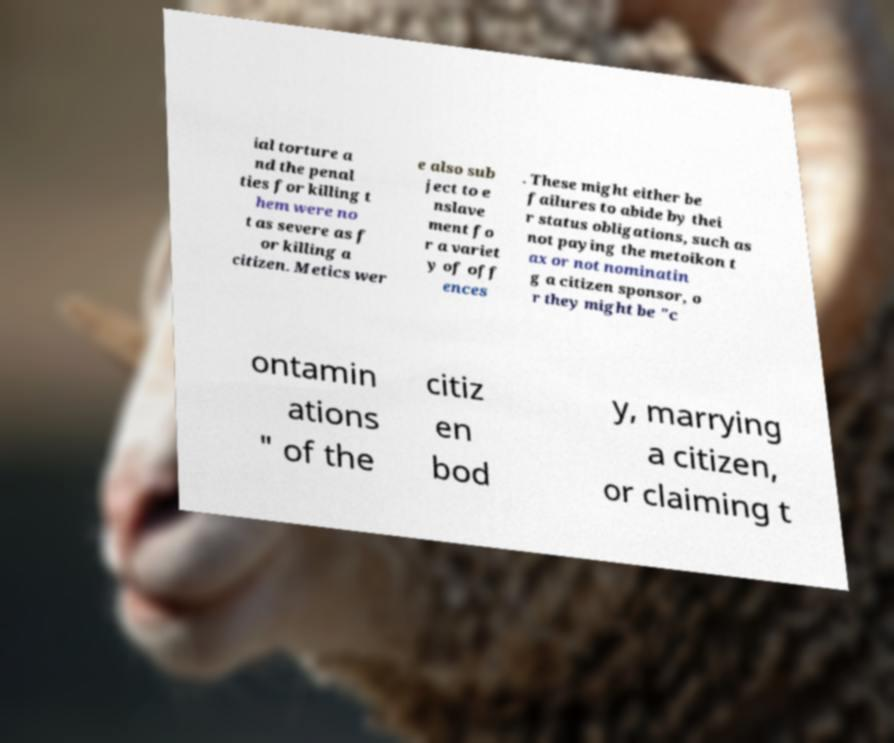There's text embedded in this image that I need extracted. Can you transcribe it verbatim? ial torture a nd the penal ties for killing t hem were no t as severe as f or killing a citizen. Metics wer e also sub ject to e nslave ment fo r a variet y of off ences . These might either be failures to abide by thei r status obligations, such as not paying the metoikon t ax or not nominatin g a citizen sponsor, o r they might be "c ontamin ations " of the citiz en bod y, marrying a citizen, or claiming t 